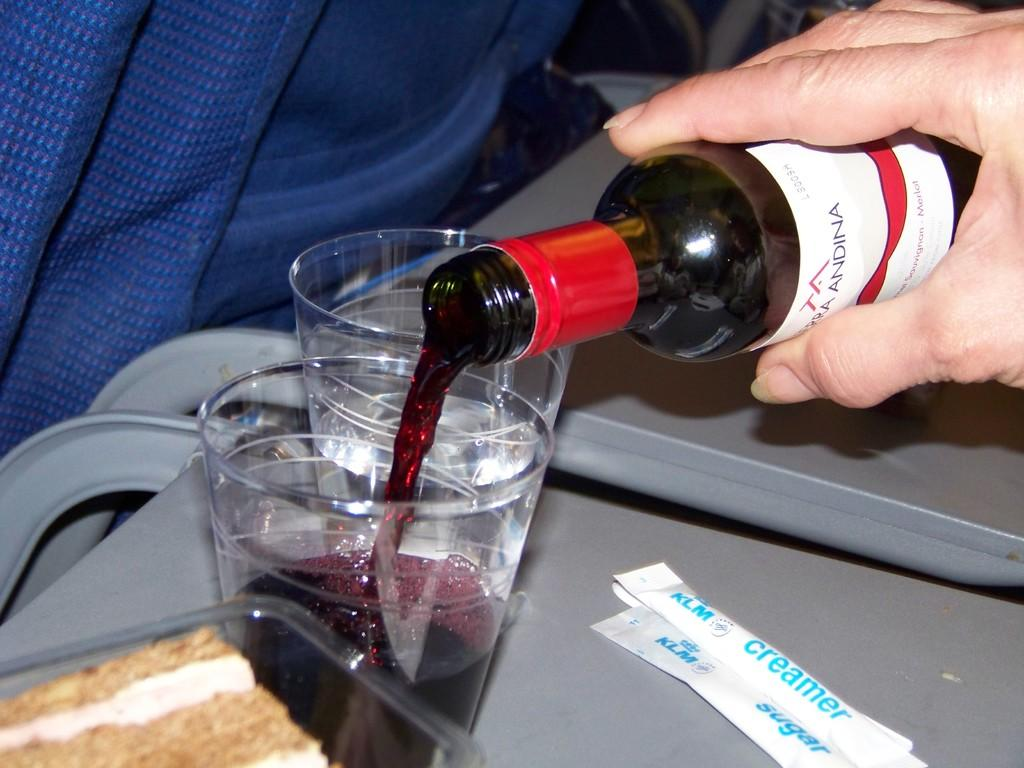<image>
Summarize the visual content of the image. a man pouring himself a bottle of red wine on a KLM flight 